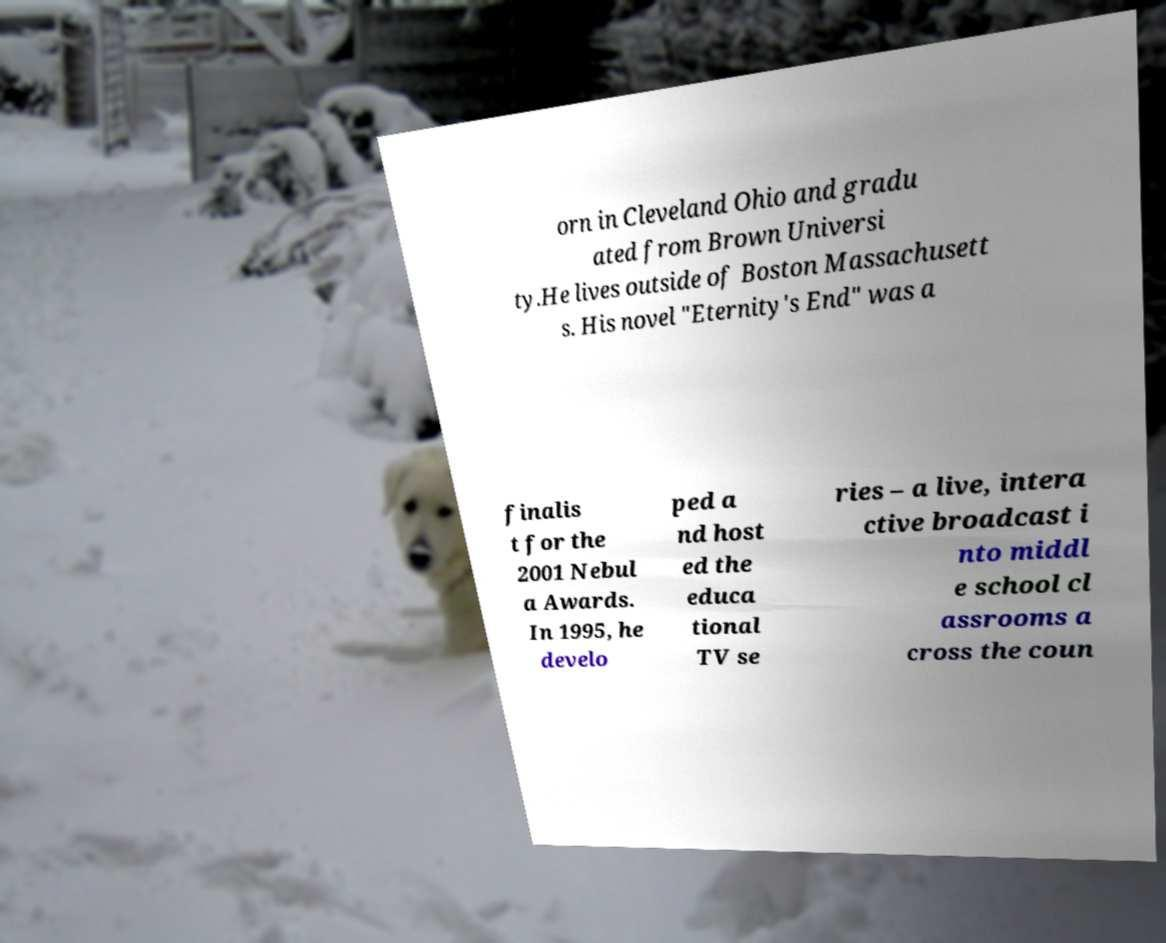What messages or text are displayed in this image? I need them in a readable, typed format. orn in Cleveland Ohio and gradu ated from Brown Universi ty.He lives outside of Boston Massachusett s. His novel "Eternity's End" was a finalis t for the 2001 Nebul a Awards. In 1995, he develo ped a nd host ed the educa tional TV se ries – a live, intera ctive broadcast i nto middl e school cl assrooms a cross the coun 